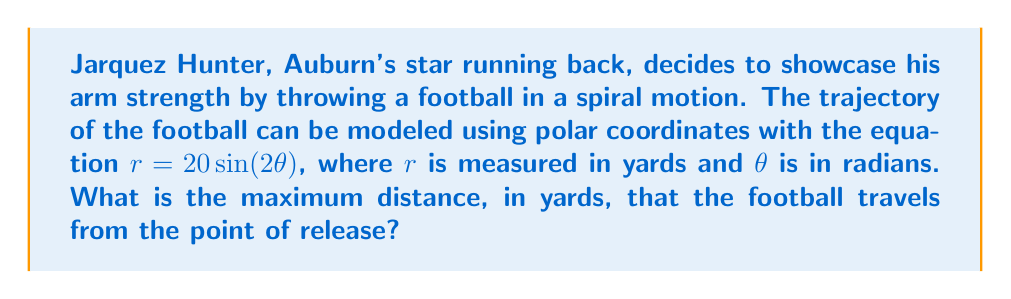Can you solve this math problem? To solve this problem, we need to follow these steps:

1) The equation $r = 20\sin(2\theta)$ is a rose curve with 2 petals because of the $\sin(2\theta)$ term.

2) The maximum distance will occur when $\sin(2\theta)$ reaches its maximum value, which is 1.

3) $\sin(2\theta) = 1$ when $2\theta = \frac{\pi}{2}, \frac{5\pi}{2}, \frac{9\pi}{2}$, etc.

4) The first maximum (which is what we're interested in for the throw) occurs when:

   $2\theta = \frac{\pi}{2}$
   $\theta = \frac{\pi}{4}$

5) To find the maximum distance, we substitute this value of $\theta$ into our original equation:

   $r = 20\sin(2 \cdot \frac{\pi}{4})$
   $r = 20\sin(\frac{\pi}{2})$
   $r = 20 \cdot 1 = 20$

Therefore, the maximum distance the football travels from the point of release is 20 yards.

[asy]
import graph;
size(200);
real r(real t) {return 20*sin(2*t);}
draw(polargraph(r,0,pi),blue);
draw(polargraph(r,pi,2pi),blue);
dot((20,pi/4),red);
label("20 yards",(10,pi/8),NE);
[/asy]
Answer: The maximum distance the football travels from the point of release is 20 yards. 